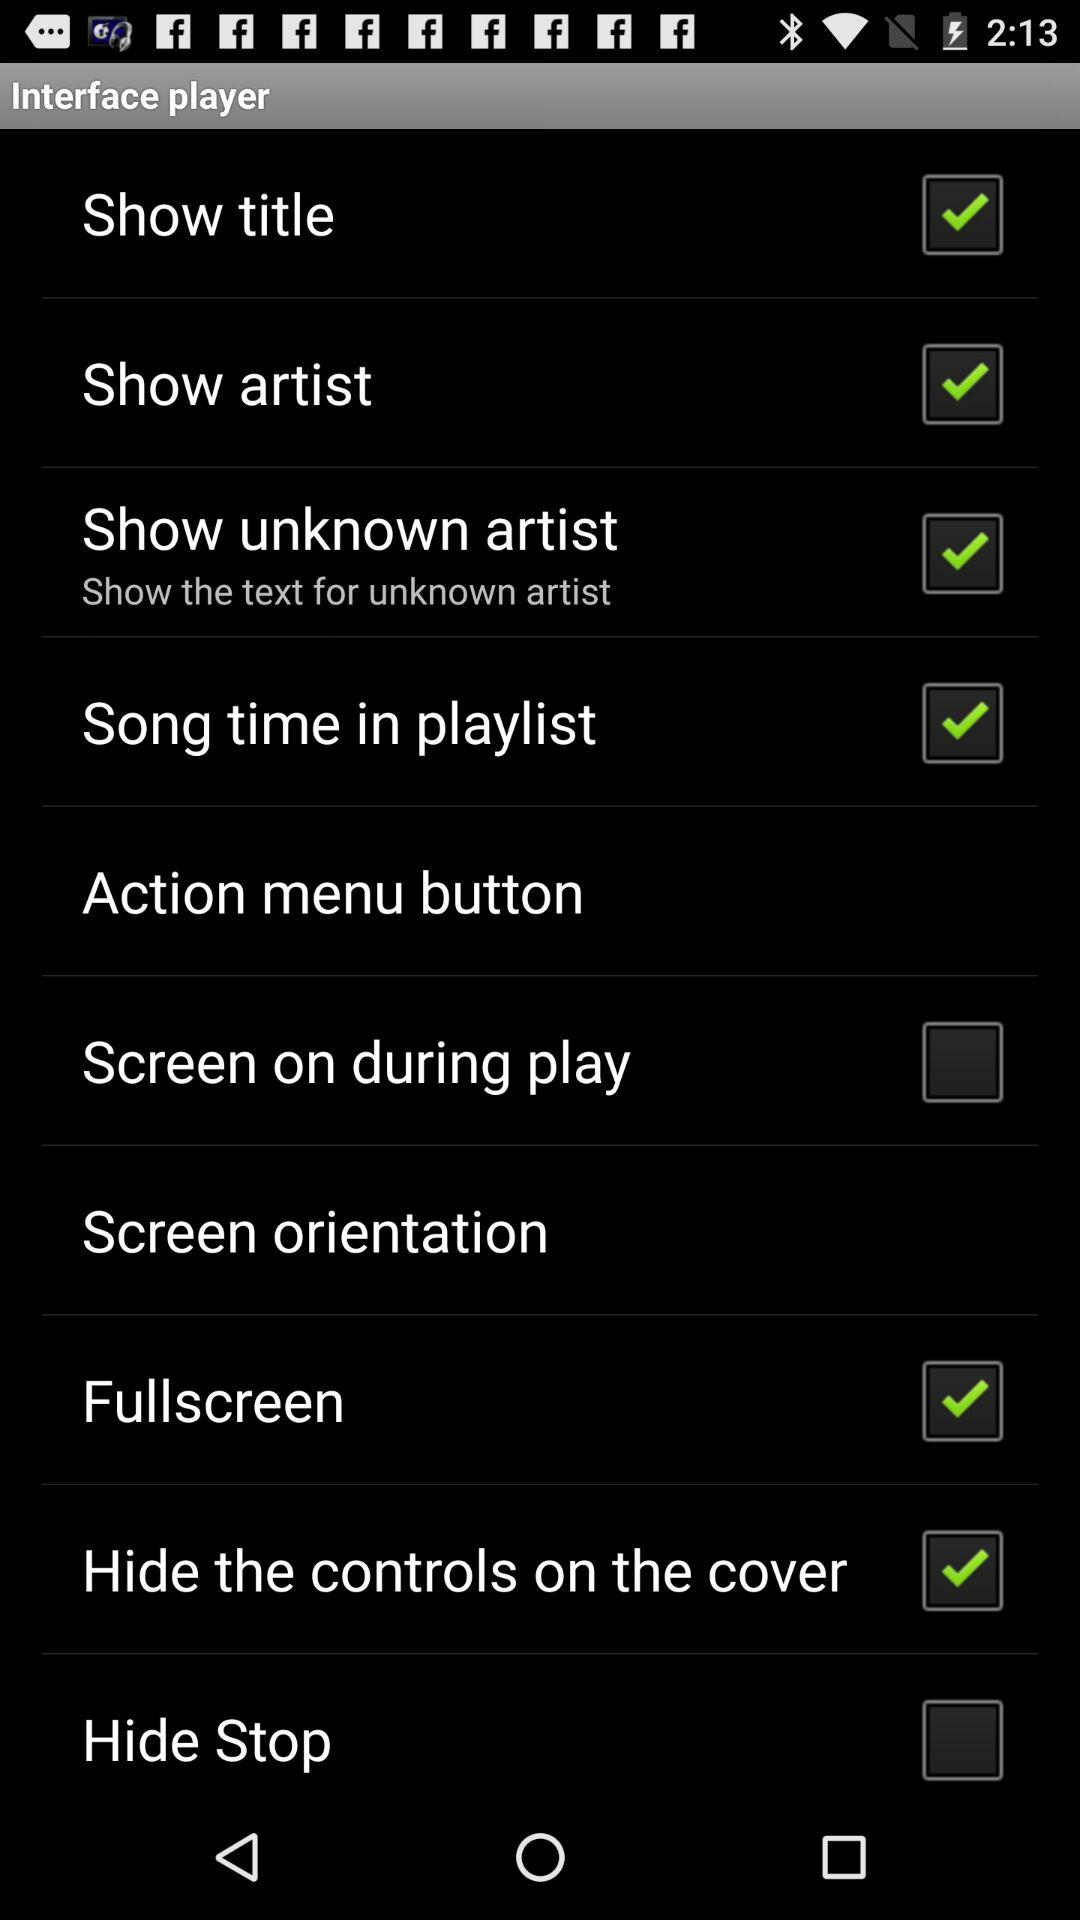What is the status of the "Screen on during play"? The status of the "Screen on during play" is "off". 